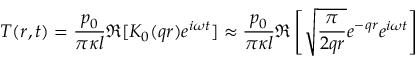Convert formula to latex. <formula><loc_0><loc_0><loc_500><loc_500>T ( r , t ) = \frac { p _ { 0 } } { \pi \kappa l } \Re { [ K _ { 0 } ( q r ) e ^ { i \omega t } ] } \approx \frac { p _ { 0 } } { \pi \kappa l } \Re \left [ \sqrt { \frac { \pi } { 2 q r } } e ^ { - q r } e ^ { i \omega t } \right ]</formula> 